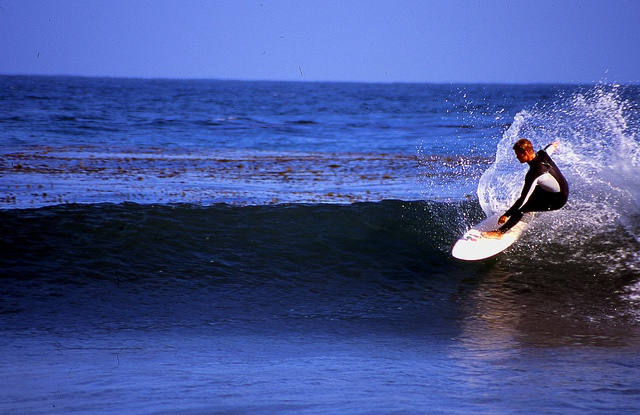Describe the objects in this image and their specific colors. I can see people in blue, black, lightgray, maroon, and darkgray tones and surfboard in blue, white, darkgray, gray, and lightpink tones in this image. 